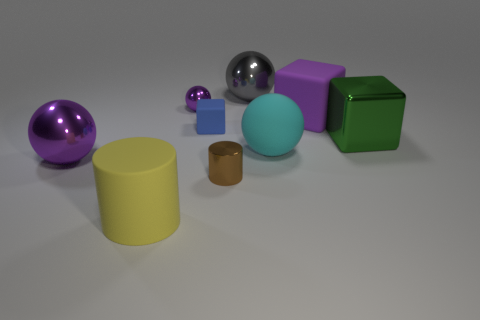What color is the big object that is both behind the small brown object and to the left of the tiny blue thing?
Ensure brevity in your answer.  Purple. There is a ball behind the small purple shiny ball in front of the large gray shiny ball; what is it made of?
Your answer should be compact. Metal. Is the size of the purple cube the same as the brown shiny object?
Ensure brevity in your answer.  No. How many big things are either brown shiny cylinders or purple metallic things?
Offer a terse response. 1. There is a blue cube; what number of blue rubber things are left of it?
Make the answer very short. 0. Are there more shiny objects on the right side of the big rubber cylinder than large green shiny cubes?
Your answer should be very brief. Yes. What shape is the big cyan thing that is the same material as the purple block?
Your answer should be compact. Sphere. What is the color of the cylinder to the right of the cylinder that is left of the tiny blue matte block?
Your response must be concise. Brown. Is the tiny purple shiny thing the same shape as the large yellow object?
Your response must be concise. No. What is the material of the large green thing that is the same shape as the small blue object?
Keep it short and to the point. Metal. 